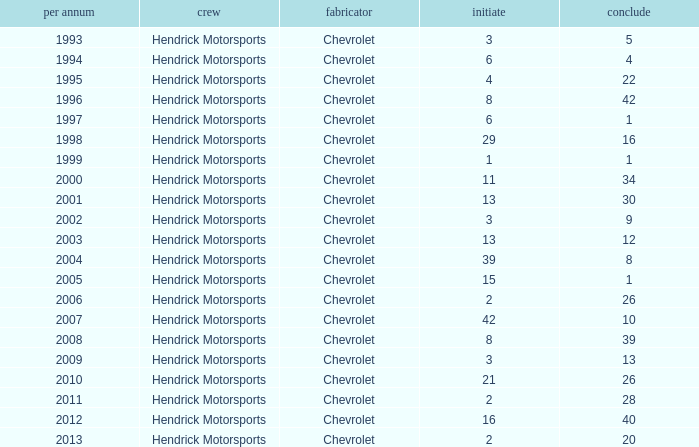What is the number of finishes having a start of 15? 1.0. 